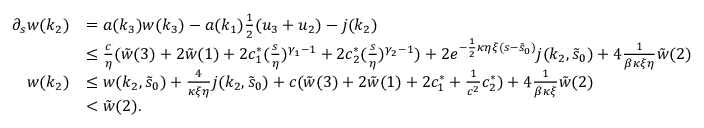Convert formula to latex. <formula><loc_0><loc_0><loc_500><loc_500>\begin{array} { r l } { \partial _ { s } w ( k _ { 2 } ) } & { = a ( k _ { 3 } ) w ( k _ { 3 } ) - a ( k _ { 1 } ) \frac { 1 } { 2 } ( u _ { 3 } + u _ { 2 } ) - j ( k _ { 2 } ) } \\ & { \leq \frac { c } \eta ( \tilde { w } ( 3 ) + 2 \tilde { w } ( 1 ) + 2 c _ { 1 } ^ { \ast } ( \frac { s } { \eta } ) ^ { \gamma _ { 1 } - 1 } + 2 c _ { 2 } ^ { \ast } ( \frac { s } { \eta } ) ^ { \gamma _ { 2 } - 1 } ) + 2 e ^ { - \frac { 1 } { 2 } \kappa \eta \xi ( s - \tilde { s } _ { 0 } ) } j ( k _ { 2 } , \tilde { s } _ { 0 } ) + 4 \frac { 1 } { \beta \kappa \xi \eta } \tilde { w } ( 2 ) } \\ { w ( k _ { 2 } ) } & { \leq w ( k _ { 2 } , \tilde { s } _ { 0 } ) + \frac { 4 } \kappa \xi \eta } j ( k _ { 2 } , \tilde { s } _ { 0 } ) + c ( \tilde { w } ( 3 ) + 2 \tilde { w } ( 1 ) + 2 c _ { 1 } ^ { \ast } + \frac { 1 } c ^ { 2 } } c _ { 2 } ^ { \ast } ) + 4 \frac { 1 } { \beta \kappa \xi } \tilde { w } ( 2 ) } \\ & { < \tilde { w } ( 2 ) . } \end{array}</formula> 